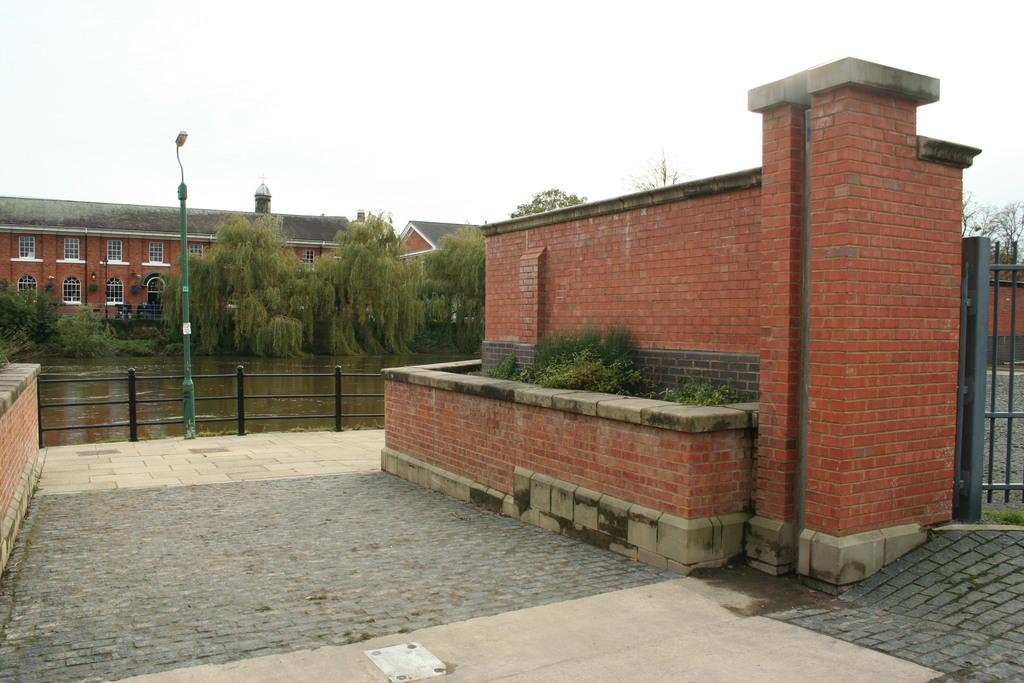What type of structures can be seen in the image? There are buildings in the image. What architectural elements are present in the image? There are walls and light poles in the image. What natural elements can be seen in the image? There are trees and plants in the image. What is the entrance feature in the image? There is a gate in the image. What can be seen in the background of the image? Water and the sky are visible in the image. Can you tell me how many servants are visible in the image? There are no servants present in the image. What type of hand can be seen exchanging items in the image? There is no hand or exchange of items depicted in the image. 